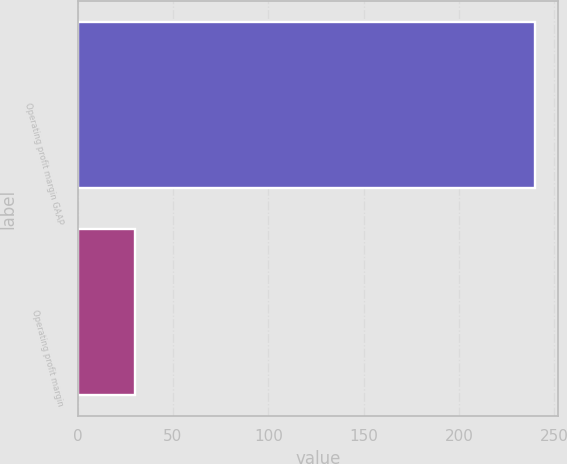Convert chart to OTSL. <chart><loc_0><loc_0><loc_500><loc_500><bar_chart><fcel>Operating profit margin GAAP<fcel>Operating profit margin<nl><fcel>240<fcel>30<nl></chart> 